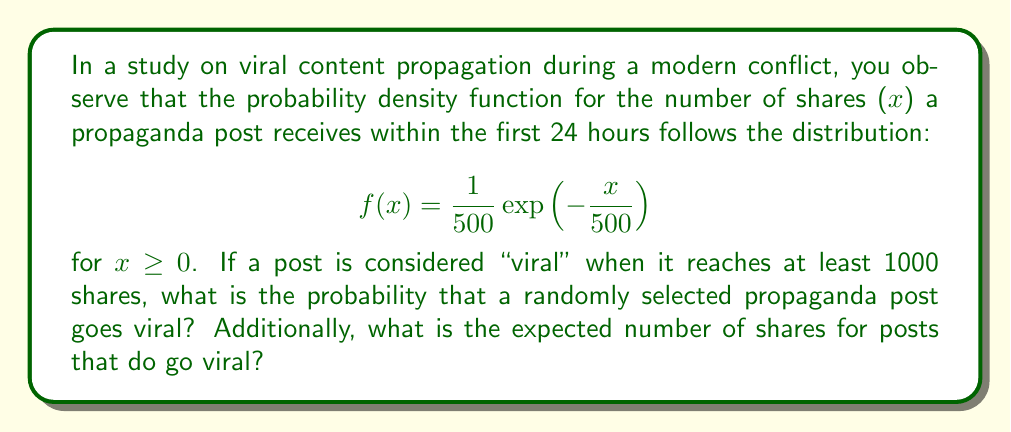Provide a solution to this math problem. To solve this problem, we'll use integration techniques and properties of the exponential distribution.

1. Probability of a post going viral:
   We need to find $P(X \geq 1000)$, where X is the number of shares.
   
   $$P(X \geq 1000) = \int_{1000}^{\infty} f(x) dx$$
   
   $$= \int_{1000}^{\infty} \frac{1}{500}\exp\left(-\frac{x}{500}\right) dx$$
   
   $$= -\exp\left(-\frac{x}{500}\right) \bigg|_{1000}^{\infty}$$
   
   $$= 0 - \left(-\exp\left(-\frac{1000}{500}\right)\right)$$
   
   $$= \exp(-2) \approx 0.1353$$

2. Expected number of shares for viral posts:
   This is a conditional expectation, $E[X|X \geq 1000]$. For the exponential distribution, we can use the memoryless property:
   
   $$E[X|X \geq 1000] = 1000 + E[X]$$
   
   Where $E[X]$ is the mean of the exponential distribution, which is equal to the rate parameter (500 in this case).
   
   $$E[X|X \geq 1000] = 1000 + 500 = 1500$$
Answer: The probability that a randomly selected propaganda post goes viral is approximately 0.1353 or 13.53%. The expected number of shares for posts that do go viral is 1500. 